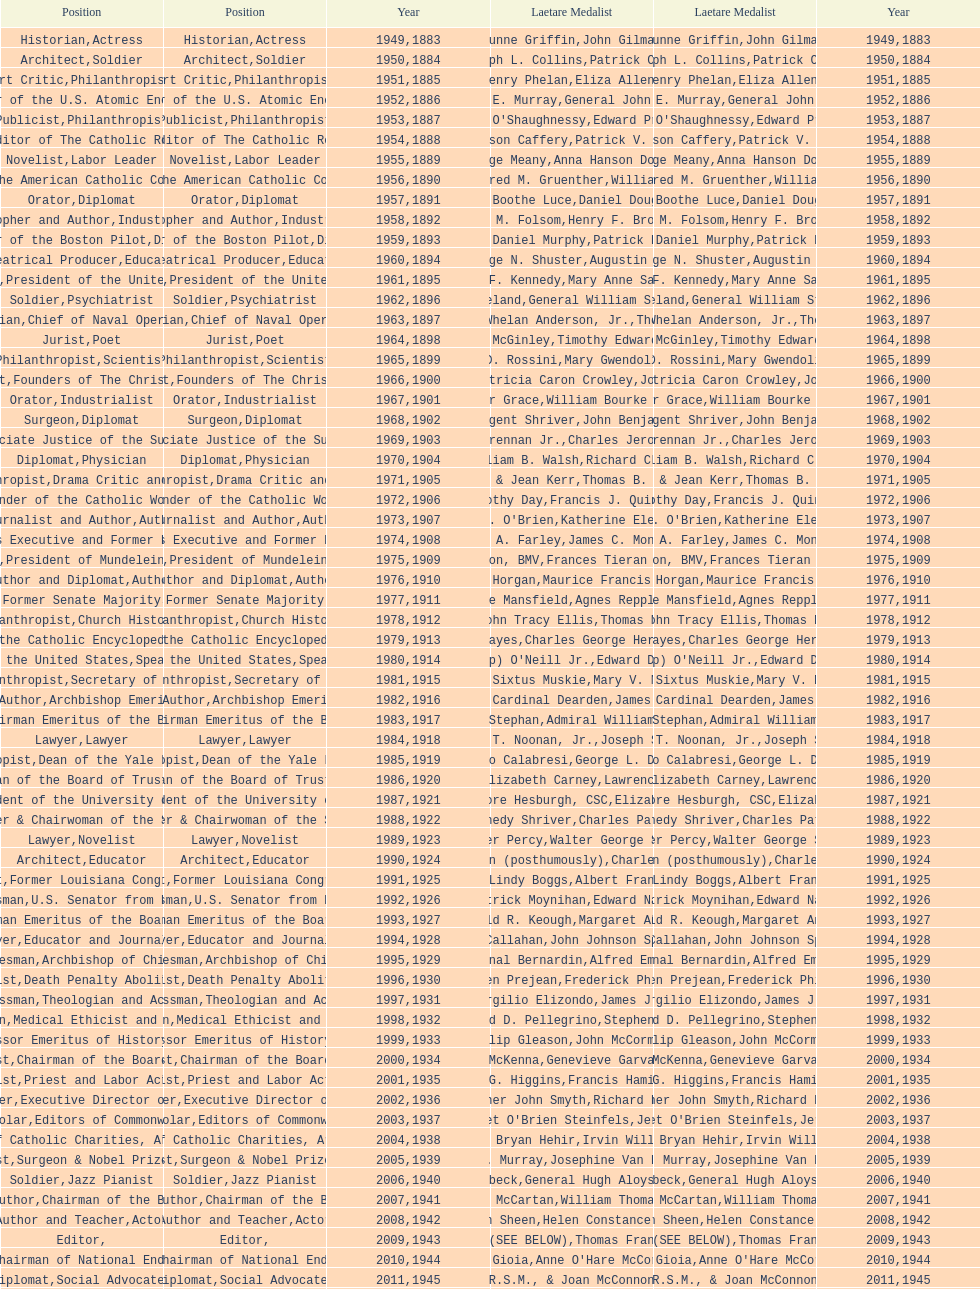Who has achieved this medal and the nobel prize simultaneously? Dr. Joseph E. Murray. 